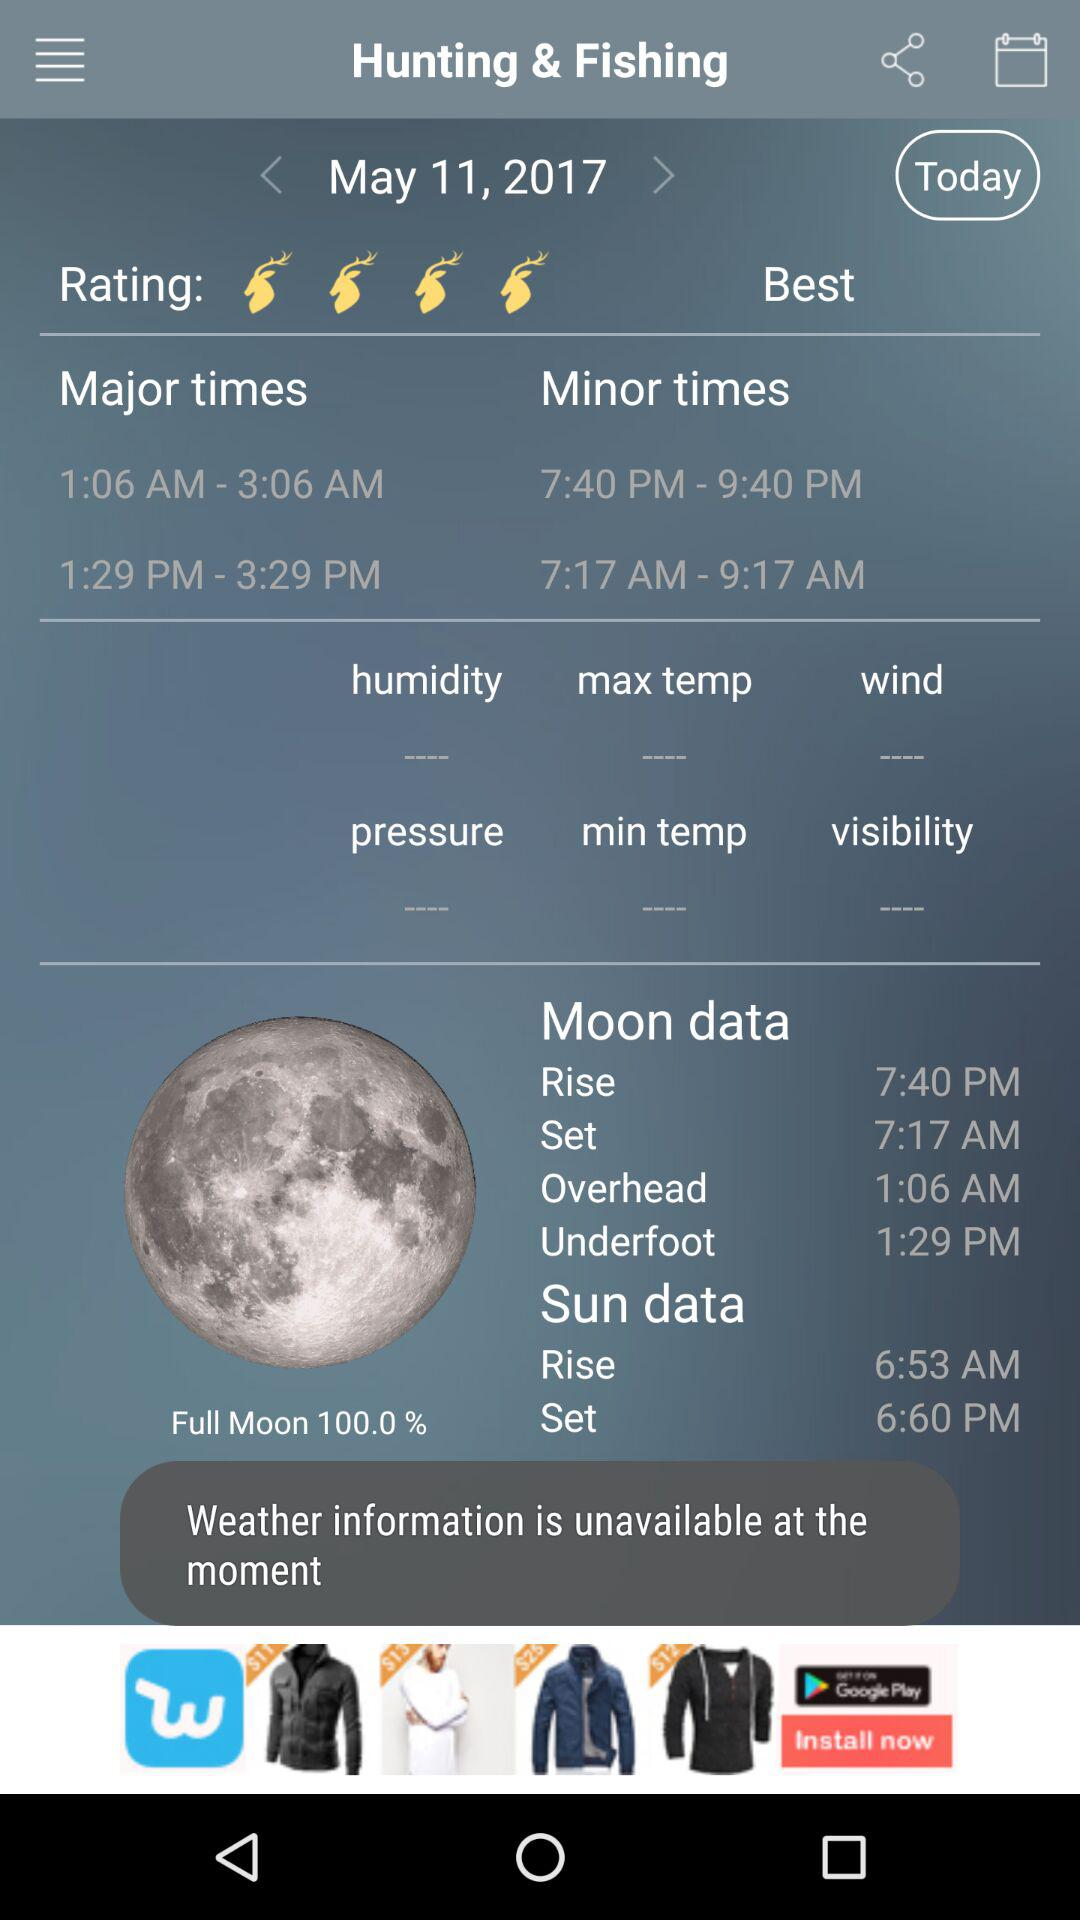What is today's date? Today's date is May 11, 2017. 